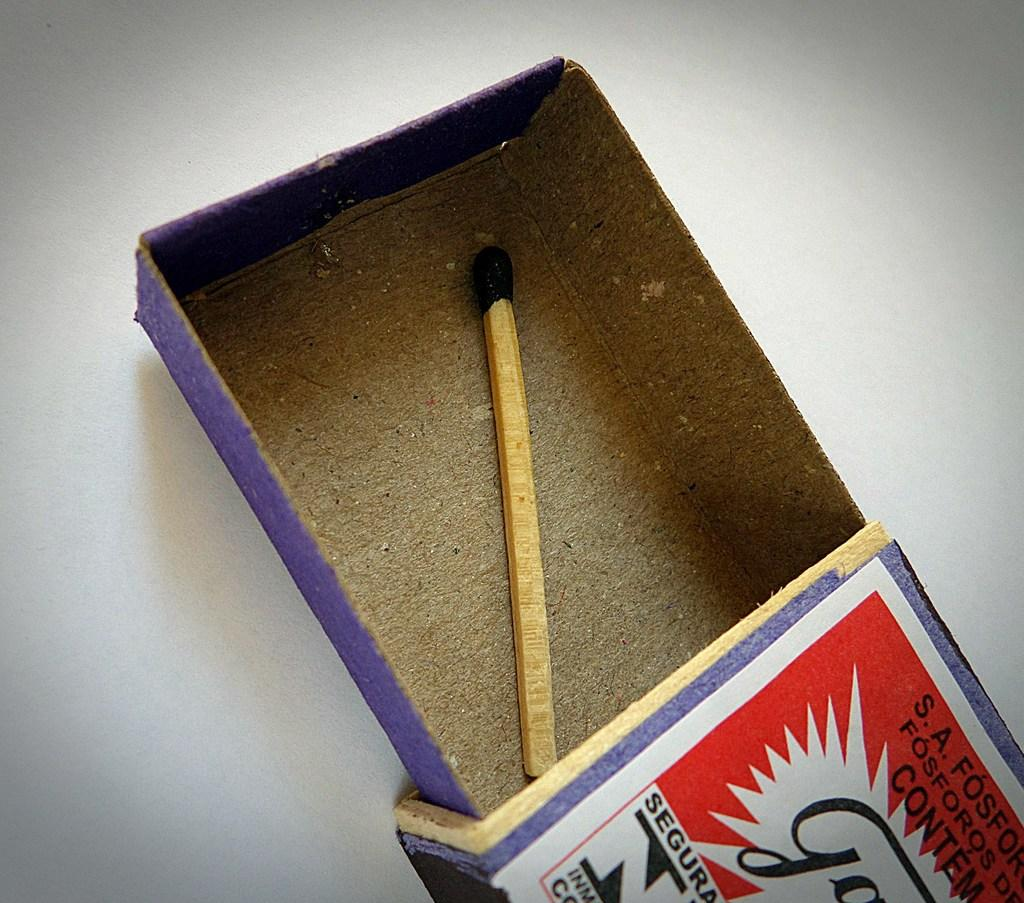<image>
Describe the image concisely. A box of matches containing only one last match has a label that starts with the S.A. 